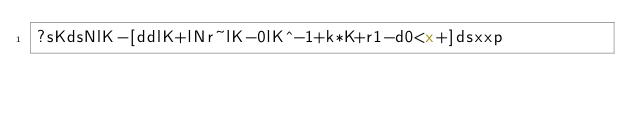Convert code to text. <code><loc_0><loc_0><loc_500><loc_500><_dc_>?sKdsNlK-[ddlK+lNr~lK-0lK^-1+k*K+r1-d0<x+]dsxxp</code> 